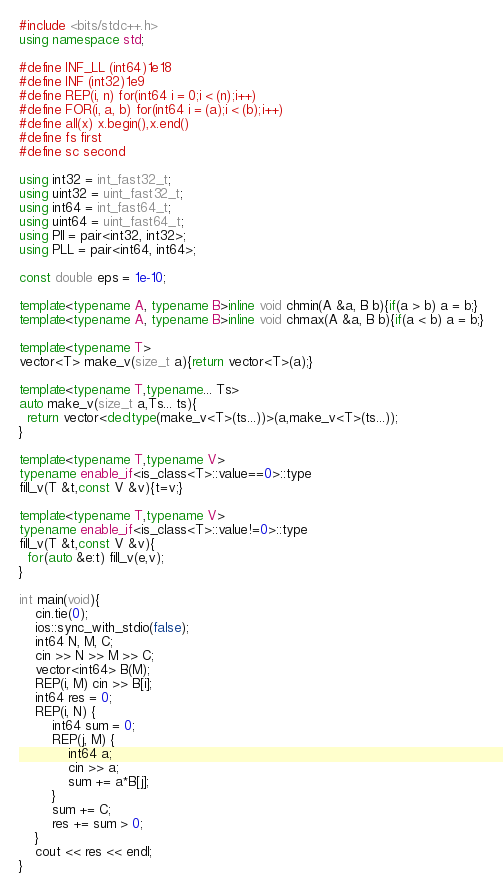<code> <loc_0><loc_0><loc_500><loc_500><_C++_>#include <bits/stdc++.h>
using namespace std;

#define INF_LL (int64)1e18
#define INF (int32)1e9
#define REP(i, n) for(int64 i = 0;i < (n);i++)
#define FOR(i, a, b) for(int64 i = (a);i < (b);i++)
#define all(x) x.begin(),x.end()
#define fs first
#define sc second

using int32 = int_fast32_t;
using uint32 = uint_fast32_t;
using int64 = int_fast64_t;
using uint64 = uint_fast64_t;
using PII = pair<int32, int32>;
using PLL = pair<int64, int64>;

const double eps = 1e-10;

template<typename A, typename B>inline void chmin(A &a, B b){if(a > b) a = b;}
template<typename A, typename B>inline void chmax(A &a, B b){if(a < b) a = b;}

template<typename T>
vector<T> make_v(size_t a){return vector<T>(a);}

template<typename T,typename... Ts>
auto make_v(size_t a,Ts... ts){
  return vector<decltype(make_v<T>(ts...))>(a,make_v<T>(ts...));
}

template<typename T,typename V>
typename enable_if<is_class<T>::value==0>::type
fill_v(T &t,const V &v){t=v;}

template<typename T,typename V>
typename enable_if<is_class<T>::value!=0>::type
fill_v(T &t,const V &v){
  for(auto &e:t) fill_v(e,v);
}

int main(void){
	cin.tie(0);
	ios::sync_with_stdio(false);
	int64 N, M, C;
	cin >> N >> M >> C;
	vector<int64> B(M);
	REP(i, M) cin >> B[i];
	int64 res = 0;
	REP(i, N) {
		int64 sum = 0;
		REP(j, M) {
			int64 a;
			cin >> a;
			sum += a*B[j];
		}
		sum += C;
		res += sum > 0;
	}
	cout << res << endl;
}
</code> 